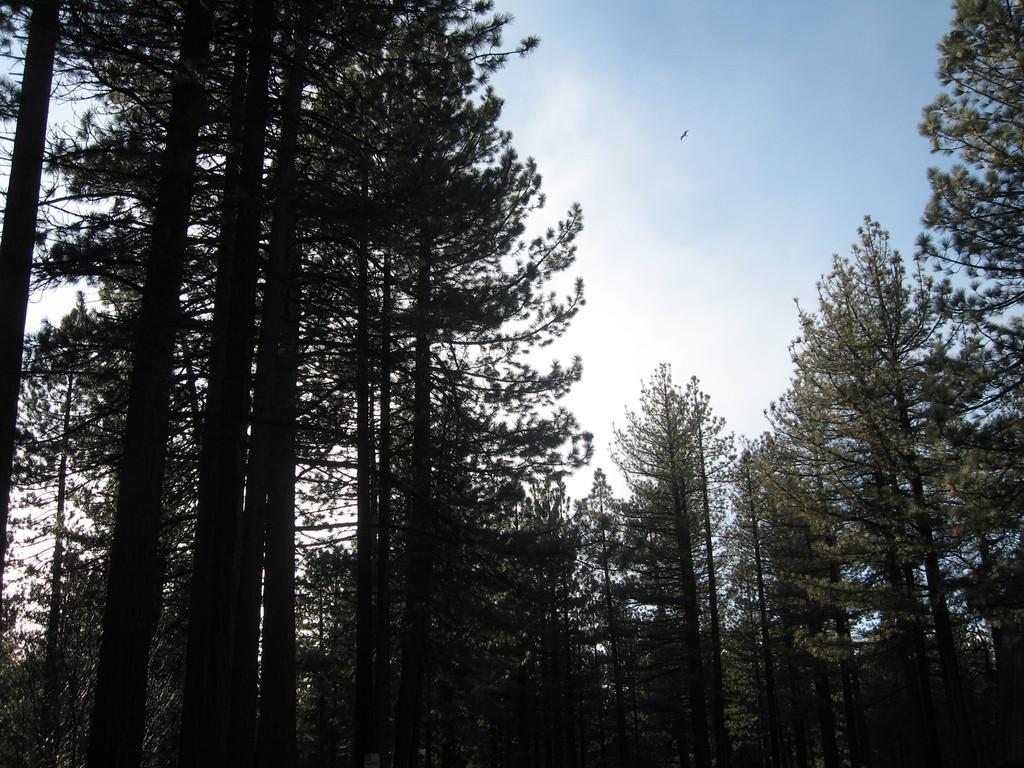Describe this image in one or two sentences. In the picture I can see trees. In the background I can see a bird is flying in the air and the sky. 